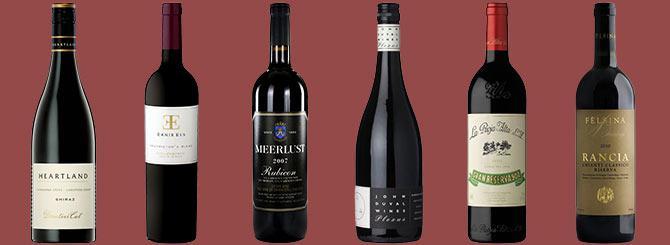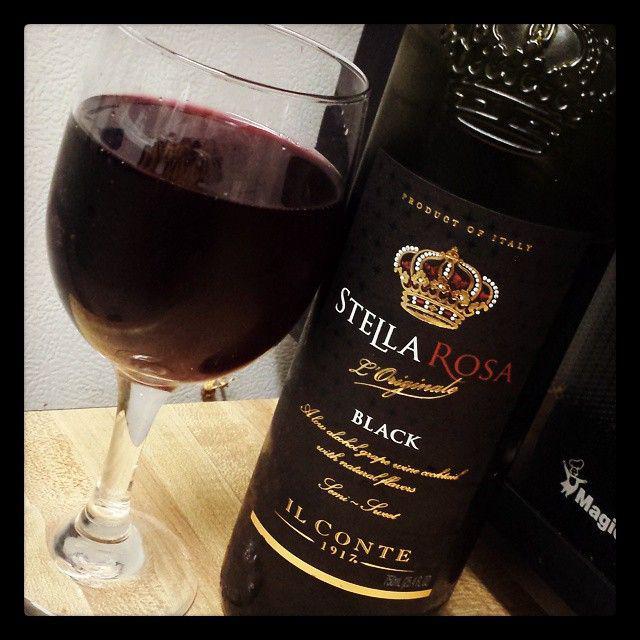The first image is the image on the left, the second image is the image on the right. For the images displayed, is the sentence "there are at least seven wine bottles in the image on the left" factually correct? Answer yes or no. No. The first image is the image on the left, the second image is the image on the right. Examine the images to the left and right. Is the description "An image shows a horizontal row of at least 7 bottles, with no space between bottles." accurate? Answer yes or no. No. 